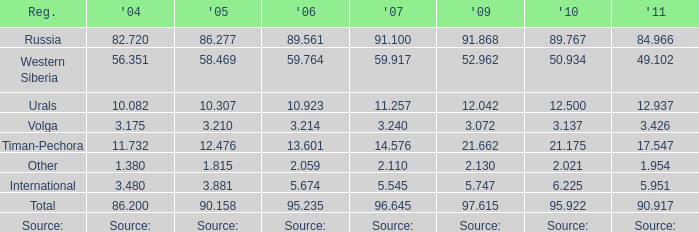What is the 2004 Lukoil oil prodroduction when in 2011 oil production 90.917 million tonnes? 86.2. 